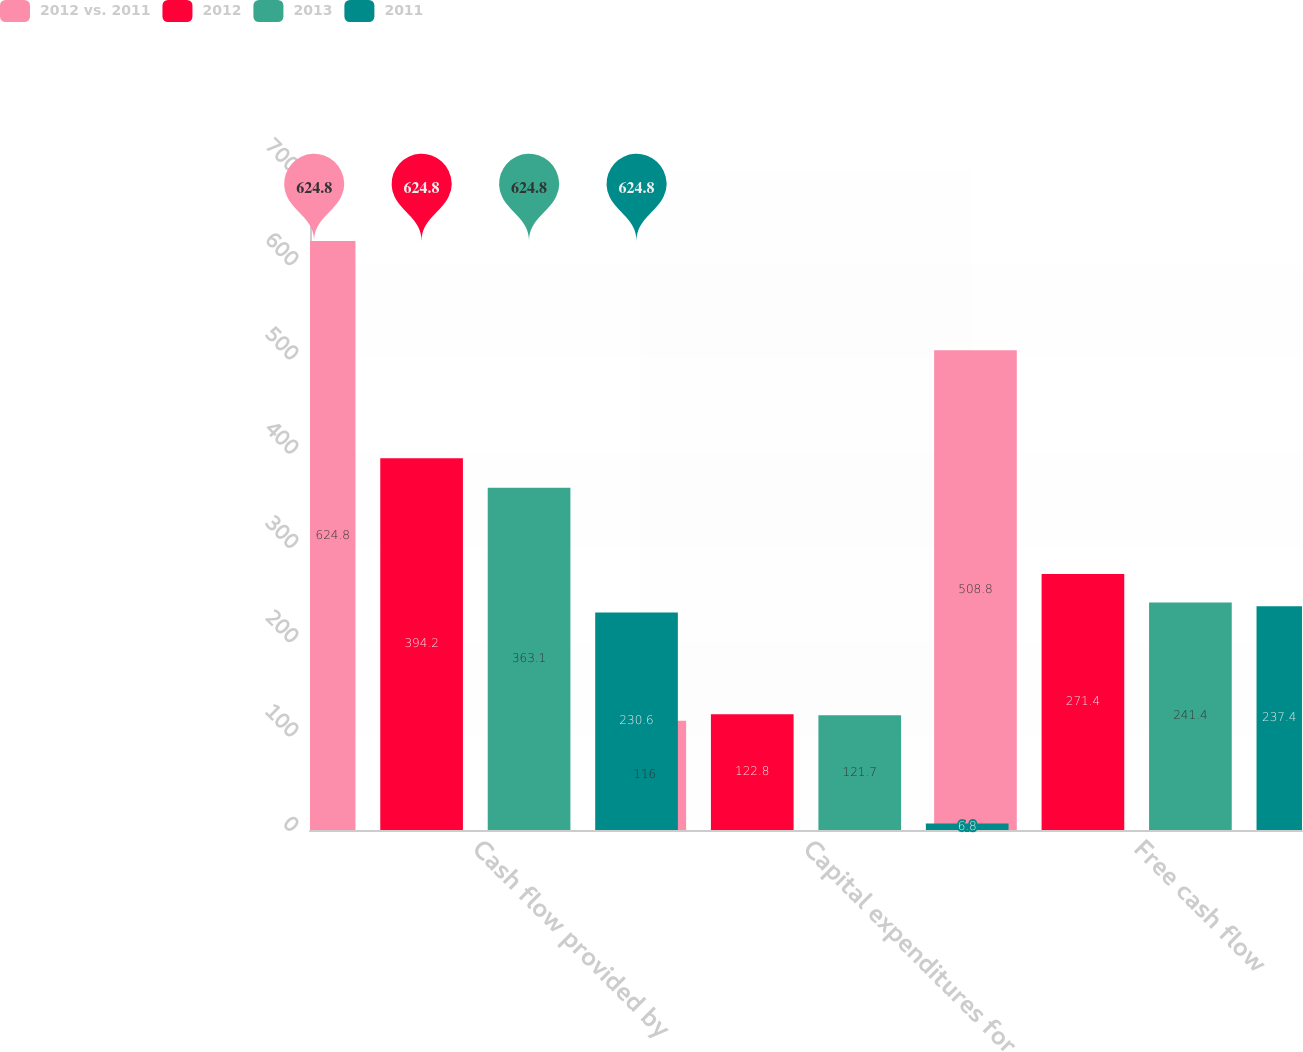<chart> <loc_0><loc_0><loc_500><loc_500><stacked_bar_chart><ecel><fcel>Cash flow provided by<fcel>Capital expenditures for<fcel>Free cash flow<nl><fcel>2012 vs. 2011<fcel>624.8<fcel>116<fcel>508.8<nl><fcel>2012<fcel>394.2<fcel>122.8<fcel>271.4<nl><fcel>2013<fcel>363.1<fcel>121.7<fcel>241.4<nl><fcel>2011<fcel>230.6<fcel>6.8<fcel>237.4<nl></chart> 